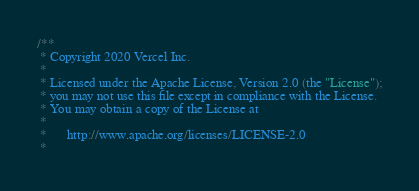Convert code to text. <code><loc_0><loc_0><loc_500><loc_500><_CSS_>/**
 * Copyright 2020 Vercel Inc.
 *
 * Licensed under the Apache License, Version 2.0 (the "License");
 * you may not use this file except in compliance with the License.
 * You may obtain a copy of the License at
 *
 *      http://www.apache.org/licenses/LICENSE-2.0
 *</code> 